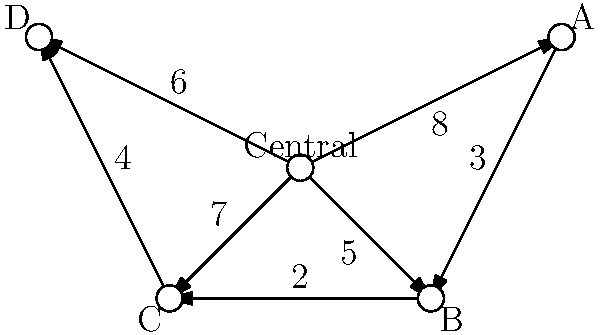As a supplier of railway parts, you need to optimize the distribution of components from your central warehouse to four regional warehouses (A, B, C, and D). The weighted graph represents the transportation costs between warehouses, where the weights indicate the cost in thousands of dollars. What is the minimum cost to ensure all regional warehouses are supplied, either directly from the central warehouse or through other regional warehouses? To solve this problem, we need to find the minimum spanning tree (MST) of the given weighted graph. The MST will represent the most cost-effective way to connect all warehouses. We can use Kruskal's algorithm to find the MST:

1. Sort all edges by weight in ascending order:
   (B-C, 2), (A-B, 3), (C-D, 4), (Central-B, 5), (Central-D, 6), (Central-C, 7), (Central-A, 8)

2. Start with an empty set of edges and add edges one by one, ensuring no cycles are formed:
   - Add (B-C, 2)
   - Add (A-B, 3)
   - Add (C-D, 4)
   - Add (Central-B, 5)

3. After adding these edges, we have connected all vertices without forming any cycles. The MST is complete.

4. Calculate the total cost by summing the weights of the selected edges:
   $2 + 3 + 4 + 5 = 14$ thousand dollars

Therefore, the minimum cost to ensure all regional warehouses are supplied is $14,000.
Answer: $14,000 